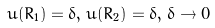<formula> <loc_0><loc_0><loc_500><loc_500>u ( R _ { 1 } ) = \delta , \, u ( R _ { 2 } ) = \delta , \, \delta \rightarrow 0</formula> 